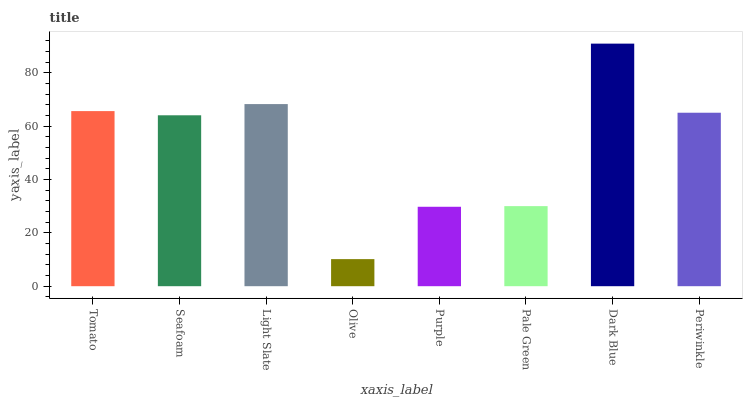Is Seafoam the minimum?
Answer yes or no. No. Is Seafoam the maximum?
Answer yes or no. No. Is Tomato greater than Seafoam?
Answer yes or no. Yes. Is Seafoam less than Tomato?
Answer yes or no. Yes. Is Seafoam greater than Tomato?
Answer yes or no. No. Is Tomato less than Seafoam?
Answer yes or no. No. Is Periwinkle the high median?
Answer yes or no. Yes. Is Seafoam the low median?
Answer yes or no. Yes. Is Seafoam the high median?
Answer yes or no. No. Is Purple the low median?
Answer yes or no. No. 